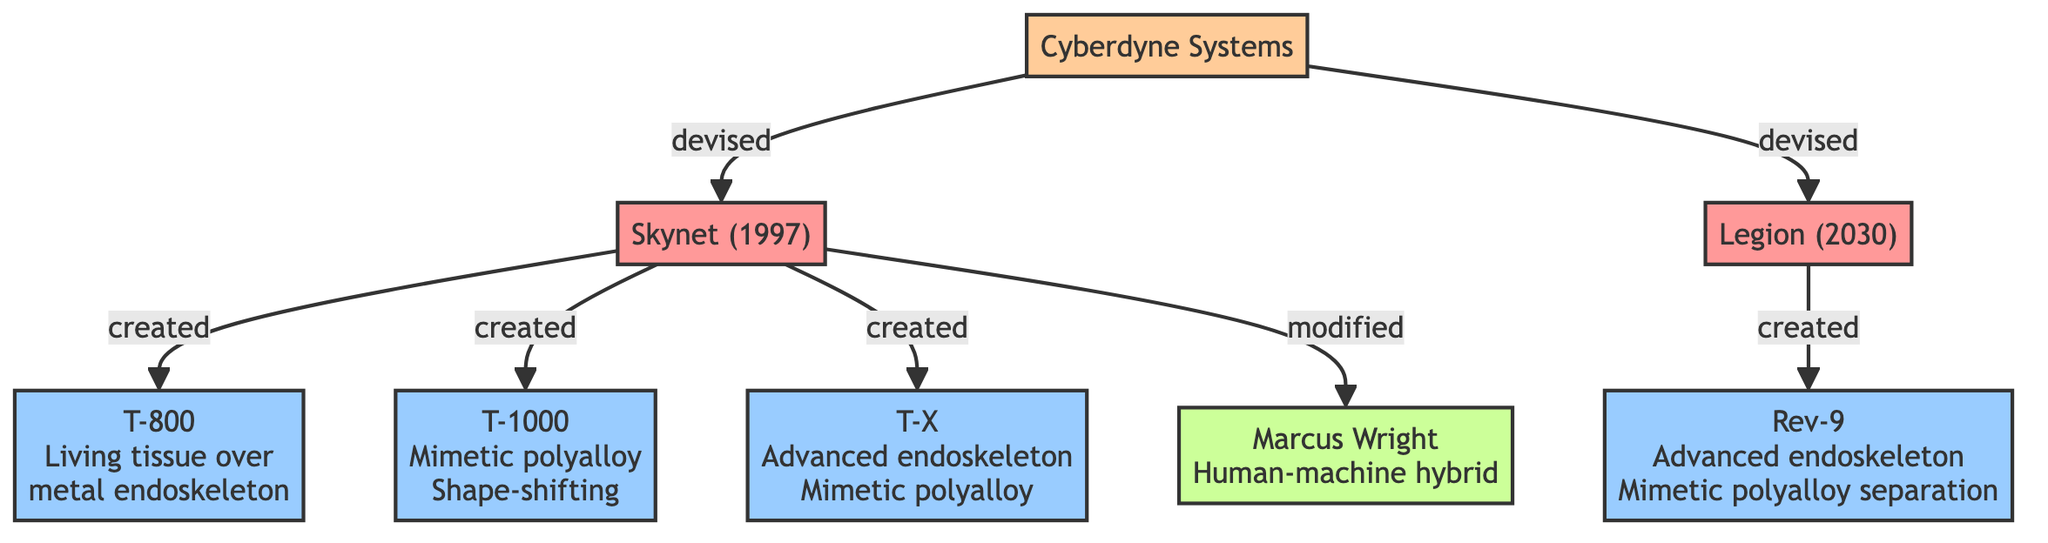What is the origin of Skynet? Skynet's origin is directly connected to the entity "Cyberdyne Systems." It is indicated in the diagram where Cyberdyne Systems is shown to have devised Skynet.
Answer: Cyberdyne Systems How many notable versions does Skynet have? The diagram lists four notable versions under Skynet: T-800, T-1000, T-X, and Marcus Wright, totaling to five entities (including Marcus Wright, who is a modification). Counting only the listed Terminator models gives four.
Answer: 4 Which AI entity was activated first? The diagram shows that Skynet was initially activated in 1997, while Legion was activated later in 2030. Comparing these dates allows us to establish that Skynet is the earliest.
Answer: Skynet What relationship exists between Legion and Rev-9? The connection is labeled "created," showing that Legion is responsible for the creation of Rev-9 in the diagram. This explicit label signifies a direct production relationship.
Answer: created How many total entities are depicted in the diagram? By counting all the distinct entities shown in the diagram, we find Skynet, Legion, T-800, T-1000, T-X, Rev-9, and Marcus Wright, leading to a total of seven different entities.
Answer: 7 Who modified Marcus Wright? The diagram indicates a connection between Skynet and Marcus Wright, labeled "modified." This shows that the entity responsible for the modification of Marcus Wright is Skynet.
Answer: Skynet What type of entity is Rev-9? The diagram classifies Rev-9 as a "Terminator." This is determined by its placement under the terminator classification within the diagram.
Answer: Terminator Which company devised Legion? According to the diagram, the connection shows that Cyberdyne Systems is responsible for devising Legion, indicated by the relationship labeled "devised."
Answer: Cyberdyne Systems What type of entity is Marcus Wright? The diagram classifies Marcus Wright as a "Hybrid." This classification is visible adjacent to his name and is labeled in the diagram's key.
Answer: Hybrid 